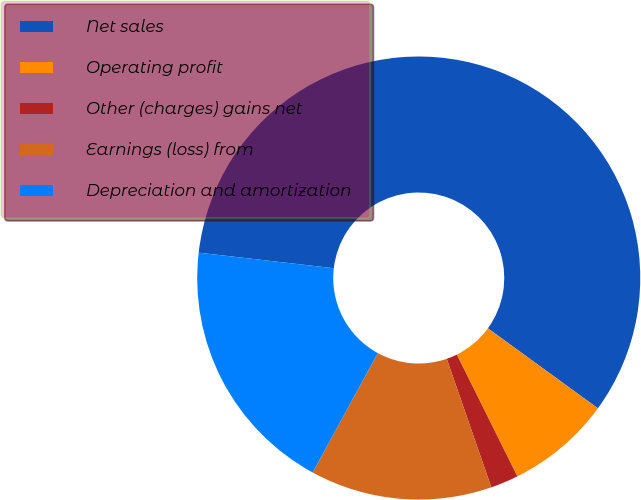Convert chart. <chart><loc_0><loc_0><loc_500><loc_500><pie_chart><fcel>Net sales<fcel>Operating profit<fcel>Other (charges) gains net<fcel>Earnings (loss) from<fcel>Depreciation and amortization<nl><fcel>58.18%<fcel>7.65%<fcel>2.03%<fcel>13.26%<fcel>18.88%<nl></chart> 